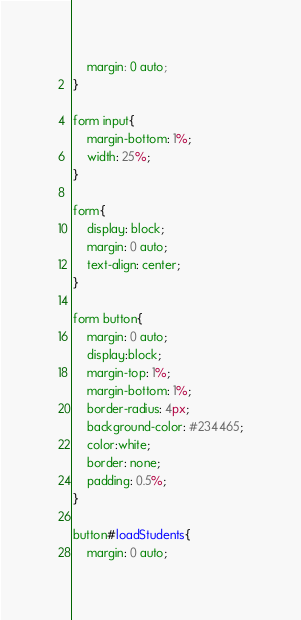<code> <loc_0><loc_0><loc_500><loc_500><_CSS_>    margin: 0 auto;
}

form input{
    margin-bottom: 1%;
    width: 25%;
}

form{
    display: block;
    margin: 0 auto;
    text-align: center;
}

form button{
    margin: 0 auto;
    display:block;
    margin-top: 1%;
    margin-bottom: 1%;
    border-radius: 4px;
    background-color: #234465;
    color:white;
    border: none;
    padding: 0.5%;
}

button#loadStudents{
    margin: 0 auto;</code> 